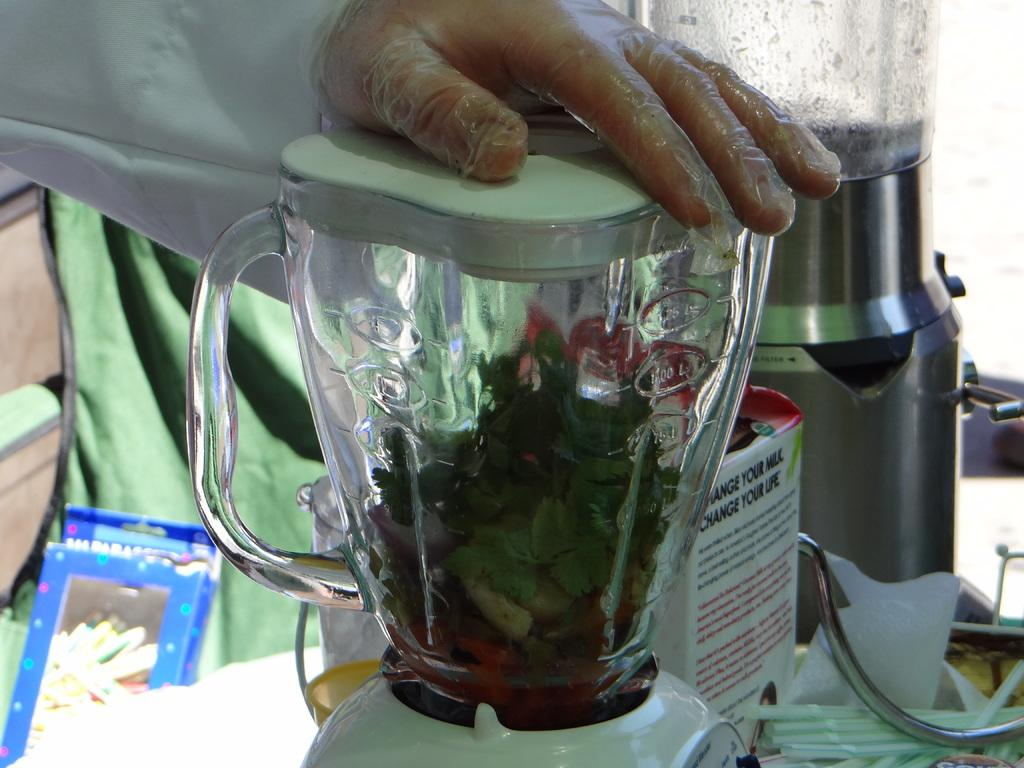Provide a one-sentence caption for the provided image. A man holding the top of a blender that says Change your life on the side. 